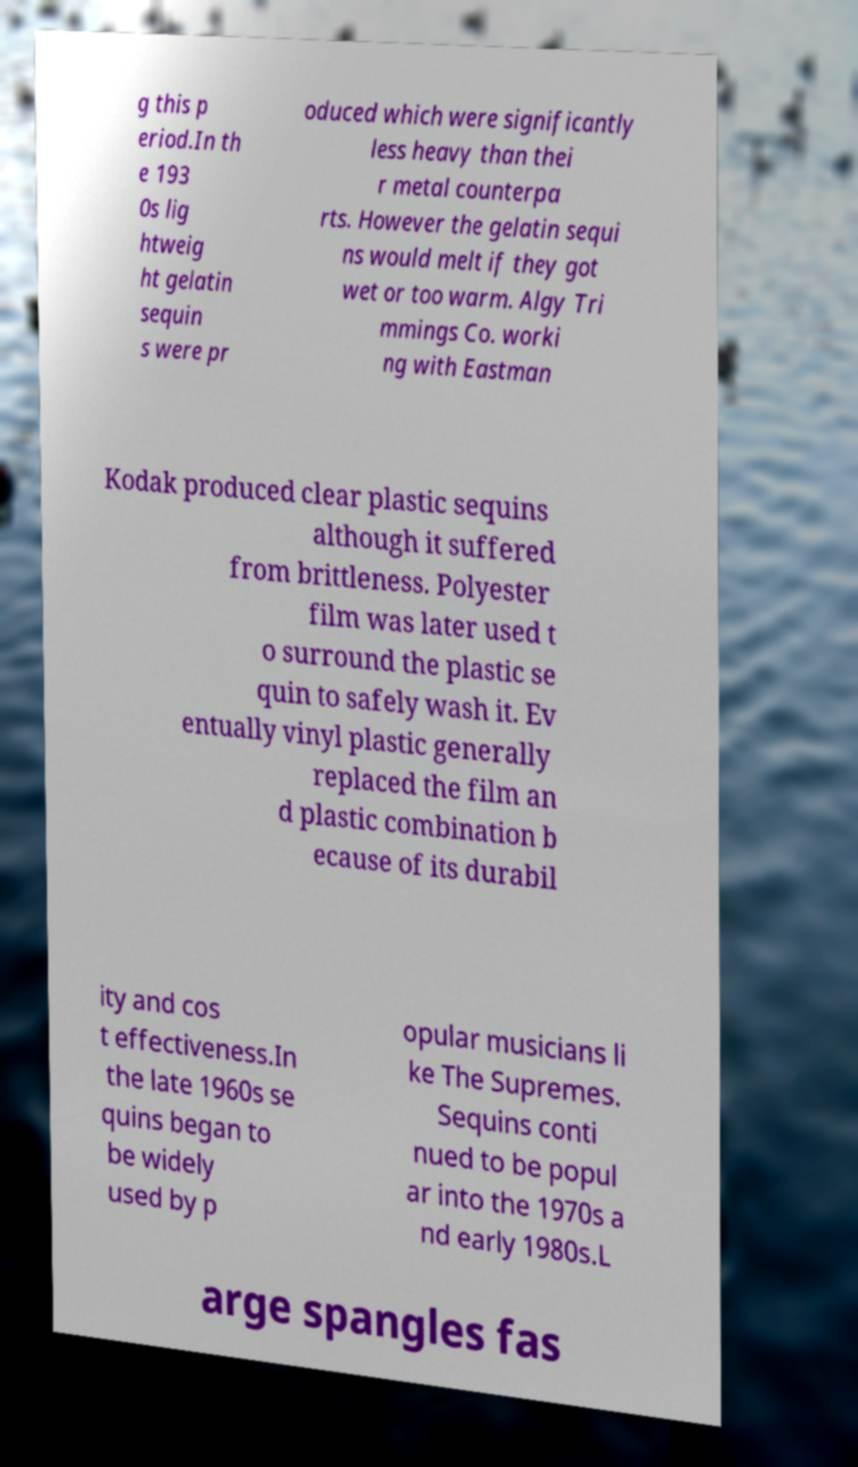Could you assist in decoding the text presented in this image and type it out clearly? g this p eriod.In th e 193 0s lig htweig ht gelatin sequin s were pr oduced which were significantly less heavy than thei r metal counterpa rts. However the gelatin sequi ns would melt if they got wet or too warm. Algy Tri mmings Co. worki ng with Eastman Kodak produced clear plastic sequins although it suffered from brittleness. Polyester film was later used t o surround the plastic se quin to safely wash it. Ev entually vinyl plastic generally replaced the film an d plastic combination b ecause of its durabil ity and cos t effectiveness.In the late 1960s se quins began to be widely used by p opular musicians li ke The Supremes. Sequins conti nued to be popul ar into the 1970s a nd early 1980s.L arge spangles fas 